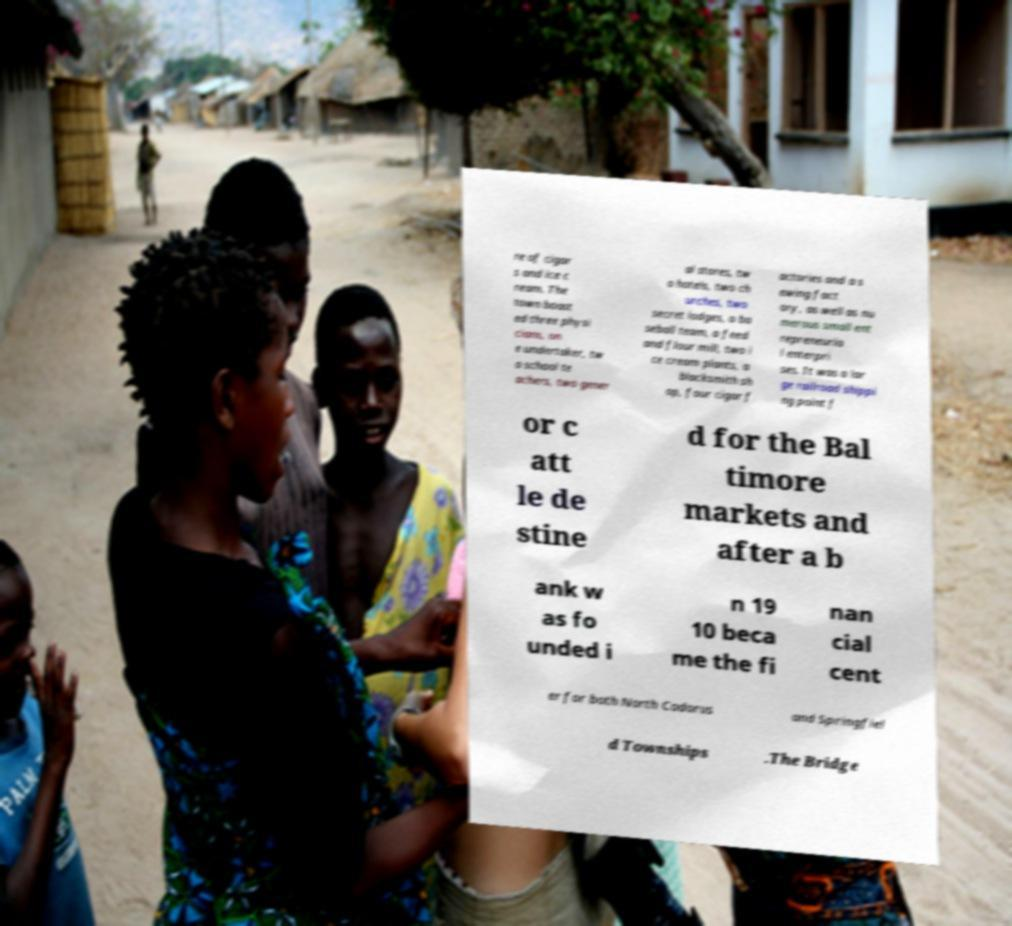Could you extract and type out the text from this image? re of cigar s and ice c ream. The town boast ed three physi cians, on e undertaker, tw o school te achers, two gener al stores, tw o hotels, two ch urches, two secret lodges, a ba seball team, a feed and flour mill, two i ce cream plants, a blacksmith sh op, four cigar f actories and a s ewing fact ory, as well as nu merous small ent repreneuria l enterpri ses. It was a lar ge railroad shippi ng point f or c att le de stine d for the Bal timore markets and after a b ank w as fo unded i n 19 10 beca me the fi nan cial cent er for both North Codorus and Springfiel d Townships .The Bridge 